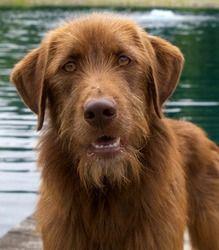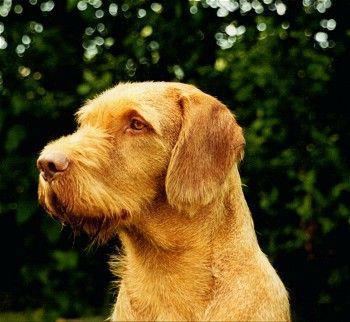The first image is the image on the left, the second image is the image on the right. For the images shown, is this caption "A dog is laying in grass." true? Answer yes or no. No. 